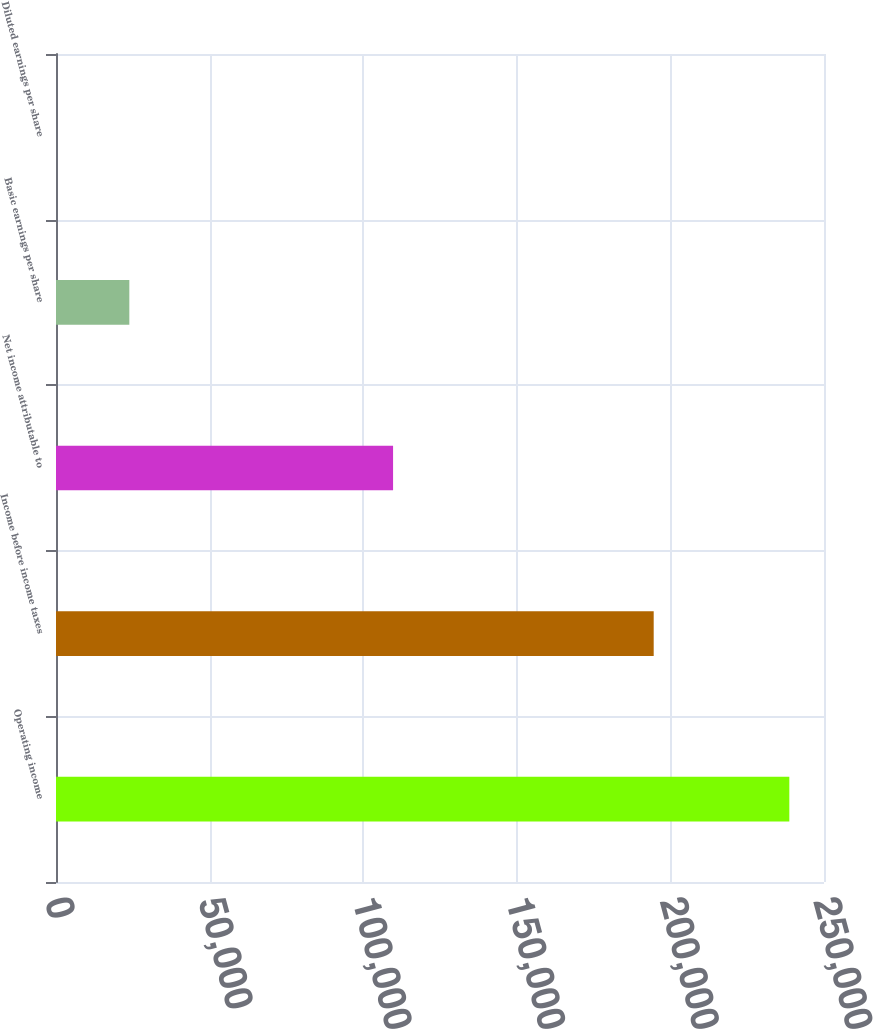<chart> <loc_0><loc_0><loc_500><loc_500><bar_chart><fcel>Operating income<fcel>Income before income taxes<fcel>Net income attributable to<fcel>Basic earnings per share<fcel>Diluted earnings per share<nl><fcel>238712<fcel>194563<fcel>109724<fcel>23872.2<fcel>1.06<nl></chart> 